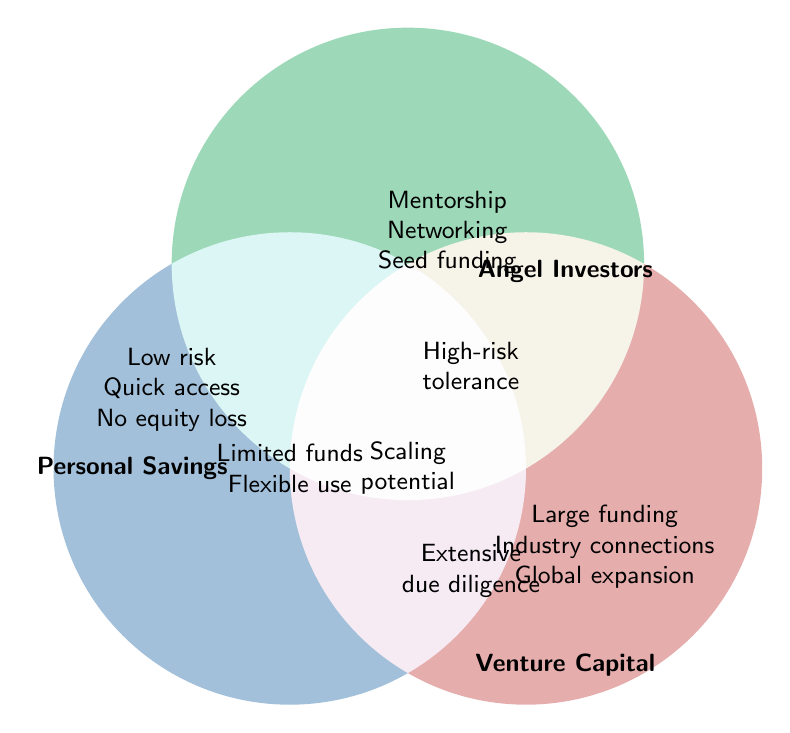What are the benefits of personal savings as a funding source? The section of the Venn Diagram labeled "Personal Savings" lists "Low risk," "Quick access," and "No equity loss" as benefits.
Answer: "Low risk," "Quick access," and "No equity loss." What kind of funding rounds do venture capitalists typically participate in? The Venn Diagram mentions "Series A/B/C rounds" in the Venture Capital section.
Answer: "Series A/B/C rounds." How does angel investing differ from venture capital in terms of investment size? Angel Investors are noted for "Smaller investments," whereas Venture Capital is noted for "Large funding rounds."
Answer: Angel Investors: "Smaller investments," Venture Capital: "Large funding rounds." Which funding sources provide industry connections? The section for Venture Capital lists "Industry connections," and Angel Investors are also mentioned for "Networking opportunities."
Answer: Angel Investors and Venture Capital What element is common to all three funding sources? The only element in the overlapping center of the Venn Diagram is "Scaling potential."
Answer: "Scaling potential." Which funding sources enable quick access to funds? The section for Personal Savings lists "Quick access."
Answer: Personal Savings Do angel investors or venture capitalists have a local or global focus? Angel Investors are mentioned to have a "Local focus," whereas Venture Capital mentions "Global expansion."
Answer: Angel Investors: "Local focus," Venture Capital: "Global expansion." What are the key added values angel investors provide beyond funding? The section for Angel Investors lists "Mentorship," "Networking," and "Industry expertise."
Answer: "Mentorship," "Networking," and "Industry expertise." Compare the flexibility of funds between personal savings and venture capital. Personal Savings include "Flexible use," while Venture Capital emphasizes "Extensive due diligence," implying stricter use conditions.
Answer: Personal Savings: "Flexible use," Venture Capital: strict due diligence What is indicated as a factor for high-risk tolerance? The section overlapping between Angel Investors and Venture Capital mentions "High-risk tolerance."
Answer: "High-risk tolerance." 